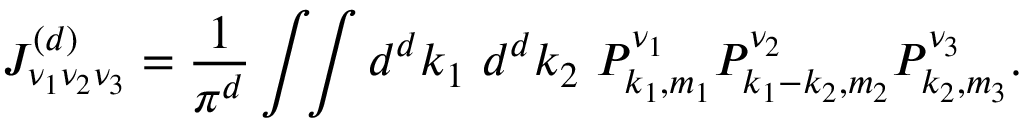Convert formula to latex. <formula><loc_0><loc_0><loc_500><loc_500>J _ { \nu _ { 1 } \nu _ { 2 } \nu _ { 3 } } ^ { ( d ) } = \frac { 1 } { \pi ^ { d } } \int \, \int { d ^ { d } k _ { 1 } d ^ { d } k _ { 2 } } P _ { k _ { 1 } , m _ { 1 } } ^ { \nu _ { 1 } } P _ { k _ { 1 } - k _ { 2 } , m _ { 2 } } ^ { \nu _ { 2 } } P _ { k _ { 2 } , m _ { 3 } } ^ { \nu _ { 3 } } .</formula> 